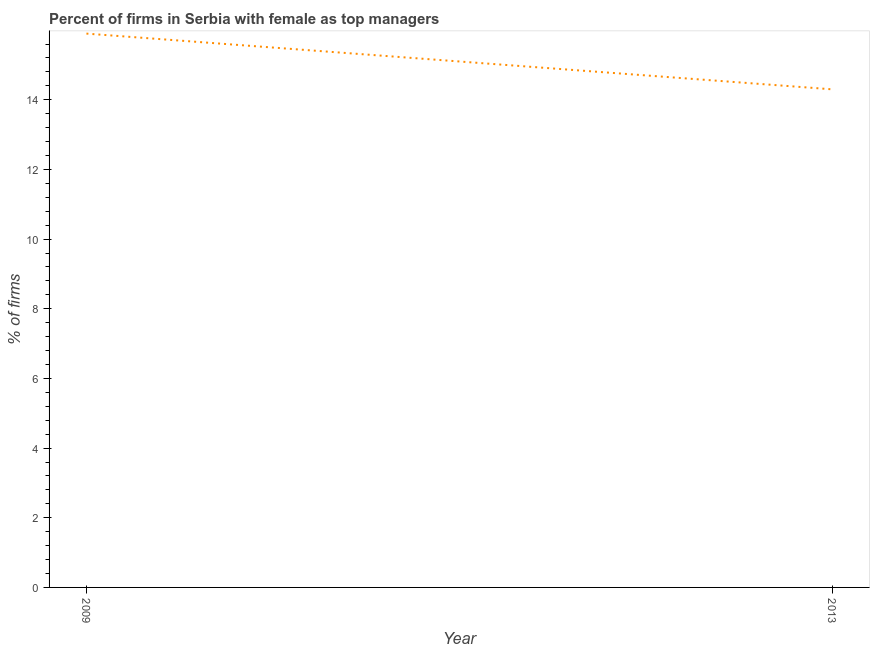What is the percentage of firms with female as top manager in 2013?
Your answer should be compact. 14.3. Across all years, what is the minimum percentage of firms with female as top manager?
Your answer should be compact. 14.3. In which year was the percentage of firms with female as top manager maximum?
Ensure brevity in your answer.  2009. In which year was the percentage of firms with female as top manager minimum?
Your answer should be compact. 2013. What is the sum of the percentage of firms with female as top manager?
Make the answer very short. 30.2. What is the difference between the percentage of firms with female as top manager in 2009 and 2013?
Offer a terse response. 1.6. What is the average percentage of firms with female as top manager per year?
Your answer should be compact. 15.1. What is the median percentage of firms with female as top manager?
Provide a short and direct response. 15.1. In how many years, is the percentage of firms with female as top manager greater than 7.2 %?
Provide a short and direct response. 2. Do a majority of the years between 2013 and 2009 (inclusive) have percentage of firms with female as top manager greater than 4 %?
Your answer should be very brief. No. What is the ratio of the percentage of firms with female as top manager in 2009 to that in 2013?
Provide a short and direct response. 1.11. Is the percentage of firms with female as top manager in 2009 less than that in 2013?
Make the answer very short. No. In how many years, is the percentage of firms with female as top manager greater than the average percentage of firms with female as top manager taken over all years?
Ensure brevity in your answer.  1. How many lines are there?
Give a very brief answer. 1. How many years are there in the graph?
Provide a succinct answer. 2. Does the graph contain any zero values?
Offer a terse response. No. Does the graph contain grids?
Your response must be concise. No. What is the title of the graph?
Ensure brevity in your answer.  Percent of firms in Serbia with female as top managers. What is the label or title of the X-axis?
Ensure brevity in your answer.  Year. What is the label or title of the Y-axis?
Give a very brief answer. % of firms. What is the % of firms of 2009?
Offer a very short reply. 15.9. What is the ratio of the % of firms in 2009 to that in 2013?
Your answer should be compact. 1.11. 